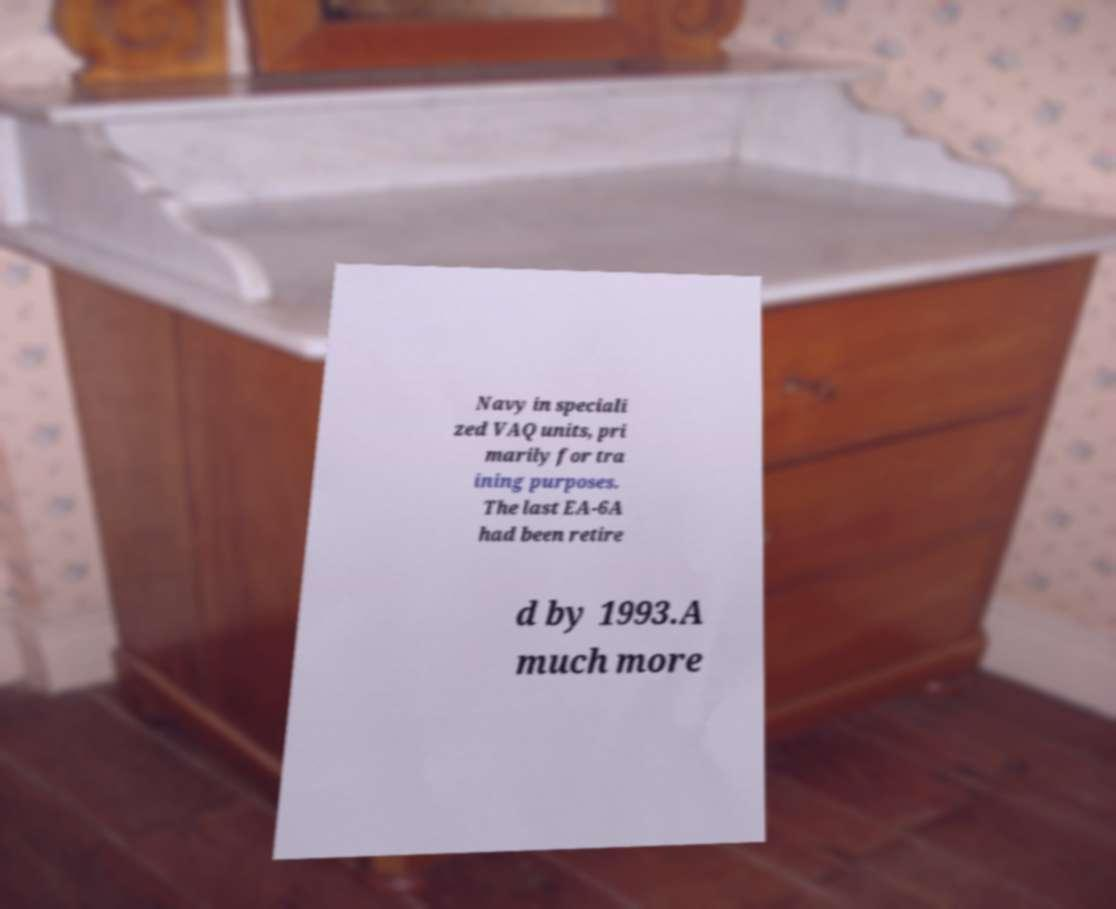Please read and relay the text visible in this image. What does it say? Navy in speciali zed VAQ units, pri marily for tra ining purposes. The last EA-6A had been retire d by 1993.A much more 